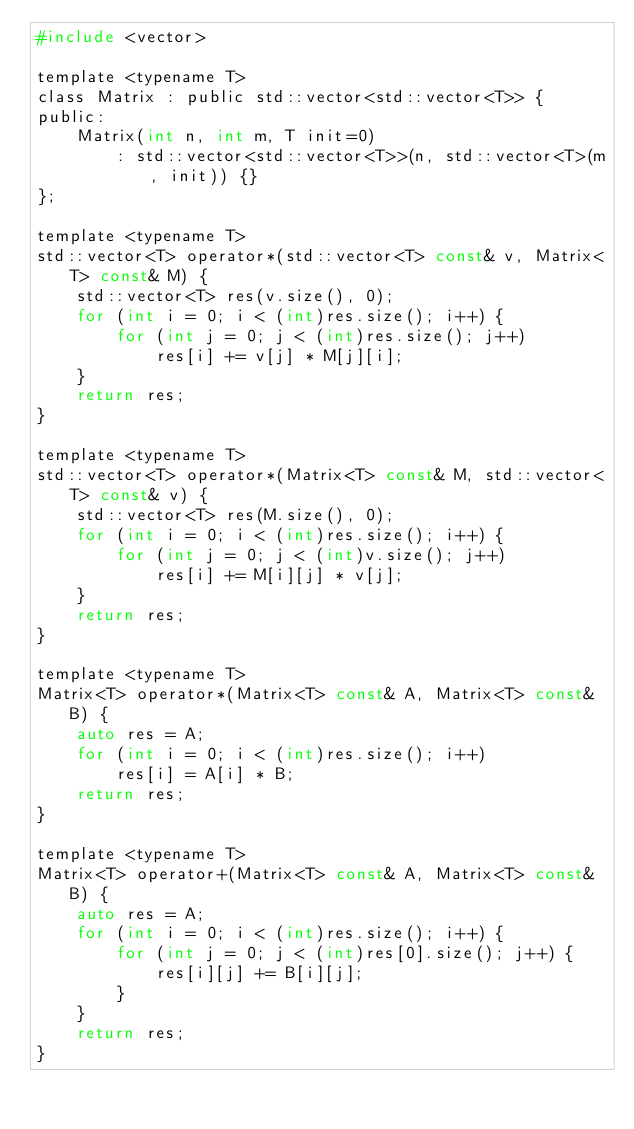Convert code to text. <code><loc_0><loc_0><loc_500><loc_500><_C_>#include <vector>

template <typename T>
class Matrix : public std::vector<std::vector<T>> {
public:
    Matrix(int n, int m, T init=0) 
        : std::vector<std::vector<T>>(n, std::vector<T>(m, init)) {}
};

template <typename T>
std::vector<T> operator*(std::vector<T> const& v, Matrix<T> const& M) {
    std::vector<T> res(v.size(), 0);
    for (int i = 0; i < (int)res.size(); i++) {
        for (int j = 0; j < (int)res.size(); j++)
            res[i] += v[j] * M[j][i];
    }
    return res;
}

template <typename T>
std::vector<T> operator*(Matrix<T> const& M, std::vector<T> const& v) {
    std::vector<T> res(M.size(), 0);
    for (int i = 0; i < (int)res.size(); i++) {
        for (int j = 0; j < (int)v.size(); j++)
            res[i] += M[i][j] * v[j];
    }
    return res;
}

template <typename T>
Matrix<T> operator*(Matrix<T> const& A, Matrix<T> const& B) {
    auto res = A;
    for (int i = 0; i < (int)res.size(); i++)
        res[i] = A[i] * B;
    return res;
}

template <typename T>
Matrix<T> operator+(Matrix<T> const& A, Matrix<T> const& B) {
    auto res = A;
    for (int i = 0; i < (int)res.size(); i++) {
        for (int j = 0; j < (int)res[0].size(); j++) {
            res[i][j] += B[i][j];
        }
    }
    return res;
}
</code> 